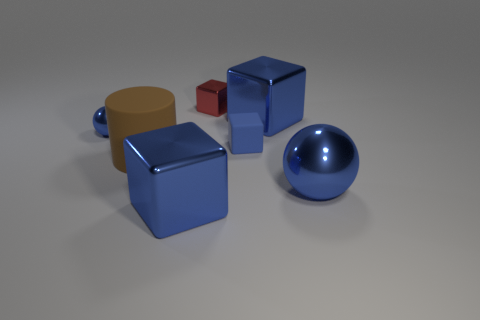Subtract all blue blocks. How many were subtracted if there are1blue blocks left? 2 Subtract all small blue blocks. How many blocks are left? 3 Subtract all purple spheres. How many blue cubes are left? 3 Subtract all red blocks. How many blocks are left? 3 Add 3 small metal cubes. How many objects exist? 10 Subtract all cyan blocks. Subtract all green cylinders. How many blocks are left? 4 Subtract all cylinders. How many objects are left? 6 Add 2 rubber cylinders. How many rubber cylinders exist? 3 Subtract 0 green cylinders. How many objects are left? 7 Subtract all large yellow rubber things. Subtract all small spheres. How many objects are left? 6 